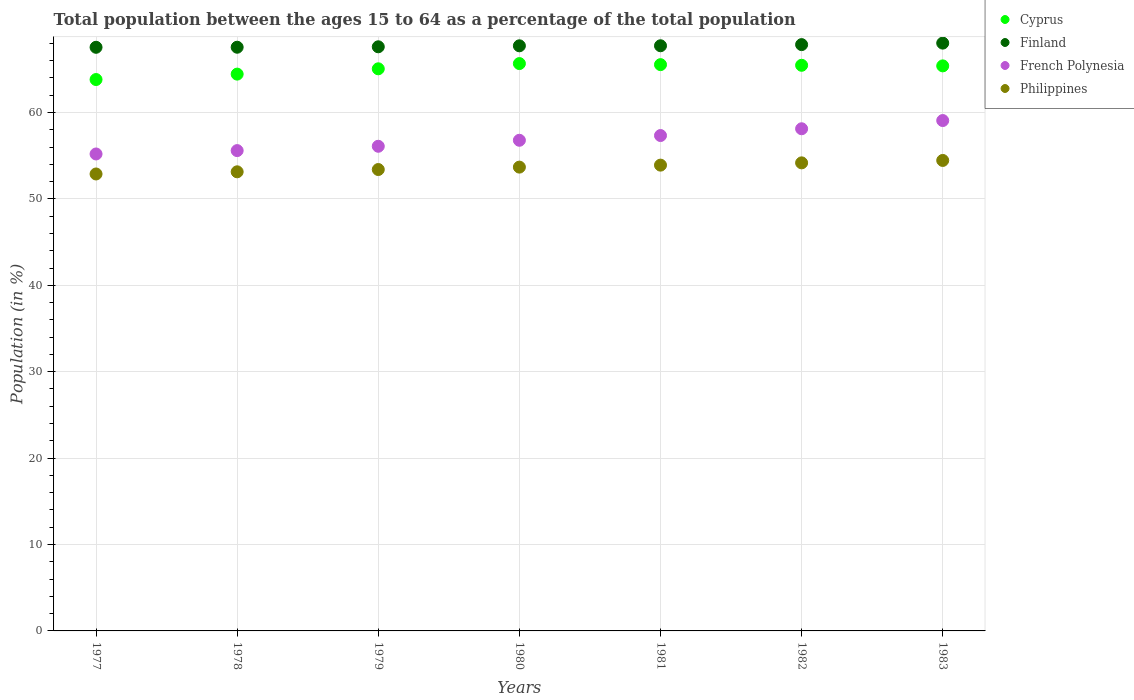How many different coloured dotlines are there?
Keep it short and to the point. 4. What is the percentage of the population ages 15 to 64 in French Polynesia in 1979?
Your answer should be very brief. 56.09. Across all years, what is the maximum percentage of the population ages 15 to 64 in Philippines?
Provide a short and direct response. 54.45. Across all years, what is the minimum percentage of the population ages 15 to 64 in French Polynesia?
Offer a very short reply. 55.2. What is the total percentage of the population ages 15 to 64 in Cyprus in the graph?
Your response must be concise. 455.35. What is the difference between the percentage of the population ages 15 to 64 in Philippines in 1978 and that in 1982?
Give a very brief answer. -1.04. What is the difference between the percentage of the population ages 15 to 64 in French Polynesia in 1980 and the percentage of the population ages 15 to 64 in Finland in 1982?
Your response must be concise. -11.07. What is the average percentage of the population ages 15 to 64 in French Polynesia per year?
Ensure brevity in your answer.  56.88. In the year 1977, what is the difference between the percentage of the population ages 15 to 64 in Finland and percentage of the population ages 15 to 64 in Philippines?
Give a very brief answer. 14.66. In how many years, is the percentage of the population ages 15 to 64 in Finland greater than 18?
Keep it short and to the point. 7. What is the ratio of the percentage of the population ages 15 to 64 in Cyprus in 1980 to that in 1982?
Provide a succinct answer. 1. Is the difference between the percentage of the population ages 15 to 64 in Finland in 1977 and 1982 greater than the difference between the percentage of the population ages 15 to 64 in Philippines in 1977 and 1982?
Your response must be concise. Yes. What is the difference between the highest and the second highest percentage of the population ages 15 to 64 in Cyprus?
Offer a terse response. 0.12. What is the difference between the highest and the lowest percentage of the population ages 15 to 64 in Philippines?
Your answer should be very brief. 1.57. Is the sum of the percentage of the population ages 15 to 64 in Cyprus in 1978 and 1982 greater than the maximum percentage of the population ages 15 to 64 in Philippines across all years?
Keep it short and to the point. Yes. Does the percentage of the population ages 15 to 64 in Cyprus monotonically increase over the years?
Make the answer very short. No. Is the percentage of the population ages 15 to 64 in Cyprus strictly greater than the percentage of the population ages 15 to 64 in Finland over the years?
Provide a short and direct response. No. Is the percentage of the population ages 15 to 64 in Philippines strictly less than the percentage of the population ages 15 to 64 in French Polynesia over the years?
Provide a short and direct response. Yes. How many dotlines are there?
Your answer should be compact. 4. Are the values on the major ticks of Y-axis written in scientific E-notation?
Give a very brief answer. No. Does the graph contain any zero values?
Your answer should be very brief. No. Where does the legend appear in the graph?
Provide a short and direct response. Top right. How are the legend labels stacked?
Your answer should be very brief. Vertical. What is the title of the graph?
Offer a terse response. Total population between the ages 15 to 64 as a percentage of the total population. Does "Egypt, Arab Rep." appear as one of the legend labels in the graph?
Offer a very short reply. No. What is the Population (in %) of Cyprus in 1977?
Your answer should be very brief. 63.81. What is the Population (in %) of Finland in 1977?
Keep it short and to the point. 67.54. What is the Population (in %) of French Polynesia in 1977?
Offer a very short reply. 55.2. What is the Population (in %) in Philippines in 1977?
Offer a terse response. 52.88. What is the Population (in %) of Cyprus in 1978?
Make the answer very short. 64.44. What is the Population (in %) of Finland in 1978?
Keep it short and to the point. 67.55. What is the Population (in %) of French Polynesia in 1978?
Keep it short and to the point. 55.59. What is the Population (in %) of Philippines in 1978?
Offer a terse response. 53.13. What is the Population (in %) of Cyprus in 1979?
Provide a succinct answer. 65.05. What is the Population (in %) of Finland in 1979?
Ensure brevity in your answer.  67.6. What is the Population (in %) in French Polynesia in 1979?
Your answer should be compact. 56.09. What is the Population (in %) of Philippines in 1979?
Offer a very short reply. 53.4. What is the Population (in %) of Cyprus in 1980?
Make the answer very short. 65.66. What is the Population (in %) of Finland in 1980?
Your answer should be compact. 67.72. What is the Population (in %) of French Polynesia in 1980?
Your answer should be compact. 56.78. What is the Population (in %) in Philippines in 1980?
Your answer should be compact. 53.68. What is the Population (in %) in Cyprus in 1981?
Give a very brief answer. 65.54. What is the Population (in %) of Finland in 1981?
Your response must be concise. 67.72. What is the Population (in %) of French Polynesia in 1981?
Provide a short and direct response. 57.33. What is the Population (in %) in Philippines in 1981?
Your response must be concise. 53.91. What is the Population (in %) in Cyprus in 1982?
Give a very brief answer. 65.46. What is the Population (in %) of Finland in 1982?
Keep it short and to the point. 67.85. What is the Population (in %) of French Polynesia in 1982?
Offer a terse response. 58.11. What is the Population (in %) in Philippines in 1982?
Provide a short and direct response. 54.17. What is the Population (in %) of Cyprus in 1983?
Provide a short and direct response. 65.39. What is the Population (in %) in Finland in 1983?
Your response must be concise. 68.03. What is the Population (in %) in French Polynesia in 1983?
Your response must be concise. 59.07. What is the Population (in %) of Philippines in 1983?
Your answer should be very brief. 54.45. Across all years, what is the maximum Population (in %) in Cyprus?
Your answer should be very brief. 65.66. Across all years, what is the maximum Population (in %) of Finland?
Your answer should be compact. 68.03. Across all years, what is the maximum Population (in %) in French Polynesia?
Give a very brief answer. 59.07. Across all years, what is the maximum Population (in %) in Philippines?
Provide a short and direct response. 54.45. Across all years, what is the minimum Population (in %) in Cyprus?
Your answer should be very brief. 63.81. Across all years, what is the minimum Population (in %) of Finland?
Provide a short and direct response. 67.54. Across all years, what is the minimum Population (in %) in French Polynesia?
Provide a short and direct response. 55.2. Across all years, what is the minimum Population (in %) in Philippines?
Keep it short and to the point. 52.88. What is the total Population (in %) in Cyprus in the graph?
Offer a very short reply. 455.35. What is the total Population (in %) of Finland in the graph?
Offer a terse response. 474.01. What is the total Population (in %) of French Polynesia in the graph?
Ensure brevity in your answer.  398.17. What is the total Population (in %) of Philippines in the graph?
Offer a very short reply. 375.61. What is the difference between the Population (in %) of Cyprus in 1977 and that in 1978?
Provide a succinct answer. -0.63. What is the difference between the Population (in %) in Finland in 1977 and that in 1978?
Your answer should be very brief. -0.01. What is the difference between the Population (in %) in French Polynesia in 1977 and that in 1978?
Ensure brevity in your answer.  -0.39. What is the difference between the Population (in %) of Philippines in 1977 and that in 1978?
Your response must be concise. -0.25. What is the difference between the Population (in %) of Cyprus in 1977 and that in 1979?
Ensure brevity in your answer.  -1.24. What is the difference between the Population (in %) in Finland in 1977 and that in 1979?
Provide a short and direct response. -0.06. What is the difference between the Population (in %) in French Polynesia in 1977 and that in 1979?
Give a very brief answer. -0.89. What is the difference between the Population (in %) in Philippines in 1977 and that in 1979?
Your response must be concise. -0.52. What is the difference between the Population (in %) of Cyprus in 1977 and that in 1980?
Give a very brief answer. -1.85. What is the difference between the Population (in %) in Finland in 1977 and that in 1980?
Offer a very short reply. -0.17. What is the difference between the Population (in %) of French Polynesia in 1977 and that in 1980?
Your answer should be compact. -1.58. What is the difference between the Population (in %) in Philippines in 1977 and that in 1980?
Provide a succinct answer. -0.79. What is the difference between the Population (in %) of Cyprus in 1977 and that in 1981?
Ensure brevity in your answer.  -1.72. What is the difference between the Population (in %) of Finland in 1977 and that in 1981?
Provide a succinct answer. -0.18. What is the difference between the Population (in %) in French Polynesia in 1977 and that in 1981?
Offer a very short reply. -2.13. What is the difference between the Population (in %) in Philippines in 1977 and that in 1981?
Your answer should be compact. -1.02. What is the difference between the Population (in %) in Cyprus in 1977 and that in 1982?
Ensure brevity in your answer.  -1.65. What is the difference between the Population (in %) of Finland in 1977 and that in 1982?
Your answer should be compact. -0.31. What is the difference between the Population (in %) of French Polynesia in 1977 and that in 1982?
Give a very brief answer. -2.92. What is the difference between the Population (in %) of Philippines in 1977 and that in 1982?
Offer a very short reply. -1.29. What is the difference between the Population (in %) of Cyprus in 1977 and that in 1983?
Offer a very short reply. -1.58. What is the difference between the Population (in %) in Finland in 1977 and that in 1983?
Give a very brief answer. -0.48. What is the difference between the Population (in %) of French Polynesia in 1977 and that in 1983?
Give a very brief answer. -3.87. What is the difference between the Population (in %) of Philippines in 1977 and that in 1983?
Your answer should be very brief. -1.57. What is the difference between the Population (in %) of Cyprus in 1978 and that in 1979?
Provide a short and direct response. -0.62. What is the difference between the Population (in %) in Finland in 1978 and that in 1979?
Offer a terse response. -0.05. What is the difference between the Population (in %) in French Polynesia in 1978 and that in 1979?
Keep it short and to the point. -0.5. What is the difference between the Population (in %) in Philippines in 1978 and that in 1979?
Your response must be concise. -0.26. What is the difference between the Population (in %) in Cyprus in 1978 and that in 1980?
Your answer should be compact. -1.22. What is the difference between the Population (in %) of Finland in 1978 and that in 1980?
Provide a short and direct response. -0.16. What is the difference between the Population (in %) of French Polynesia in 1978 and that in 1980?
Your answer should be very brief. -1.2. What is the difference between the Population (in %) of Philippines in 1978 and that in 1980?
Provide a succinct answer. -0.54. What is the difference between the Population (in %) in Cyprus in 1978 and that in 1981?
Provide a short and direct response. -1.1. What is the difference between the Population (in %) in Finland in 1978 and that in 1981?
Give a very brief answer. -0.17. What is the difference between the Population (in %) of French Polynesia in 1978 and that in 1981?
Offer a very short reply. -1.74. What is the difference between the Population (in %) of Philippines in 1978 and that in 1981?
Your response must be concise. -0.77. What is the difference between the Population (in %) of Cyprus in 1978 and that in 1982?
Offer a very short reply. -1.02. What is the difference between the Population (in %) of Finland in 1978 and that in 1982?
Your response must be concise. -0.3. What is the difference between the Population (in %) in French Polynesia in 1978 and that in 1982?
Provide a succinct answer. -2.53. What is the difference between the Population (in %) of Philippines in 1978 and that in 1982?
Provide a succinct answer. -1.04. What is the difference between the Population (in %) of Cyprus in 1978 and that in 1983?
Your answer should be compact. -0.95. What is the difference between the Population (in %) of Finland in 1978 and that in 1983?
Your response must be concise. -0.48. What is the difference between the Population (in %) in French Polynesia in 1978 and that in 1983?
Your response must be concise. -3.48. What is the difference between the Population (in %) of Philippines in 1978 and that in 1983?
Ensure brevity in your answer.  -1.32. What is the difference between the Population (in %) in Cyprus in 1979 and that in 1980?
Your response must be concise. -0.6. What is the difference between the Population (in %) in Finland in 1979 and that in 1980?
Provide a succinct answer. -0.11. What is the difference between the Population (in %) in French Polynesia in 1979 and that in 1980?
Offer a terse response. -0.69. What is the difference between the Population (in %) of Philippines in 1979 and that in 1980?
Offer a terse response. -0.28. What is the difference between the Population (in %) of Cyprus in 1979 and that in 1981?
Provide a succinct answer. -0.48. What is the difference between the Population (in %) of Finland in 1979 and that in 1981?
Ensure brevity in your answer.  -0.12. What is the difference between the Population (in %) in French Polynesia in 1979 and that in 1981?
Ensure brevity in your answer.  -1.24. What is the difference between the Population (in %) in Philippines in 1979 and that in 1981?
Your response must be concise. -0.51. What is the difference between the Population (in %) in Cyprus in 1979 and that in 1982?
Your answer should be compact. -0.41. What is the difference between the Population (in %) in Finland in 1979 and that in 1982?
Give a very brief answer. -0.25. What is the difference between the Population (in %) of French Polynesia in 1979 and that in 1982?
Offer a terse response. -2.03. What is the difference between the Population (in %) of Philippines in 1979 and that in 1982?
Your answer should be compact. -0.77. What is the difference between the Population (in %) in Cyprus in 1979 and that in 1983?
Keep it short and to the point. -0.34. What is the difference between the Population (in %) in Finland in 1979 and that in 1983?
Provide a succinct answer. -0.43. What is the difference between the Population (in %) of French Polynesia in 1979 and that in 1983?
Your answer should be very brief. -2.98. What is the difference between the Population (in %) in Philippines in 1979 and that in 1983?
Your response must be concise. -1.05. What is the difference between the Population (in %) of Cyprus in 1980 and that in 1981?
Offer a terse response. 0.12. What is the difference between the Population (in %) in Finland in 1980 and that in 1981?
Offer a terse response. -0. What is the difference between the Population (in %) of French Polynesia in 1980 and that in 1981?
Offer a terse response. -0.55. What is the difference between the Population (in %) in Philippines in 1980 and that in 1981?
Offer a very short reply. -0.23. What is the difference between the Population (in %) of Cyprus in 1980 and that in 1982?
Your answer should be very brief. 0.2. What is the difference between the Population (in %) in Finland in 1980 and that in 1982?
Offer a terse response. -0.14. What is the difference between the Population (in %) of French Polynesia in 1980 and that in 1982?
Give a very brief answer. -1.33. What is the difference between the Population (in %) of Philippines in 1980 and that in 1982?
Make the answer very short. -0.49. What is the difference between the Population (in %) of Cyprus in 1980 and that in 1983?
Your response must be concise. 0.27. What is the difference between the Population (in %) of Finland in 1980 and that in 1983?
Provide a short and direct response. -0.31. What is the difference between the Population (in %) of French Polynesia in 1980 and that in 1983?
Ensure brevity in your answer.  -2.28. What is the difference between the Population (in %) in Philippines in 1980 and that in 1983?
Provide a short and direct response. -0.77. What is the difference between the Population (in %) in Cyprus in 1981 and that in 1982?
Offer a terse response. 0.07. What is the difference between the Population (in %) in Finland in 1981 and that in 1982?
Offer a terse response. -0.13. What is the difference between the Population (in %) of French Polynesia in 1981 and that in 1982?
Provide a succinct answer. -0.78. What is the difference between the Population (in %) in Philippines in 1981 and that in 1982?
Keep it short and to the point. -0.26. What is the difference between the Population (in %) in Cyprus in 1981 and that in 1983?
Your response must be concise. 0.14. What is the difference between the Population (in %) in Finland in 1981 and that in 1983?
Make the answer very short. -0.31. What is the difference between the Population (in %) of French Polynesia in 1981 and that in 1983?
Ensure brevity in your answer.  -1.74. What is the difference between the Population (in %) of Philippines in 1981 and that in 1983?
Your answer should be very brief. -0.54. What is the difference between the Population (in %) in Cyprus in 1982 and that in 1983?
Your answer should be very brief. 0.07. What is the difference between the Population (in %) in Finland in 1982 and that in 1983?
Your answer should be very brief. -0.17. What is the difference between the Population (in %) of French Polynesia in 1982 and that in 1983?
Keep it short and to the point. -0.95. What is the difference between the Population (in %) of Philippines in 1982 and that in 1983?
Your response must be concise. -0.28. What is the difference between the Population (in %) of Cyprus in 1977 and the Population (in %) of Finland in 1978?
Make the answer very short. -3.74. What is the difference between the Population (in %) in Cyprus in 1977 and the Population (in %) in French Polynesia in 1978?
Offer a terse response. 8.22. What is the difference between the Population (in %) of Cyprus in 1977 and the Population (in %) of Philippines in 1978?
Your answer should be compact. 10.68. What is the difference between the Population (in %) of Finland in 1977 and the Population (in %) of French Polynesia in 1978?
Keep it short and to the point. 11.96. What is the difference between the Population (in %) in Finland in 1977 and the Population (in %) in Philippines in 1978?
Offer a very short reply. 14.41. What is the difference between the Population (in %) in French Polynesia in 1977 and the Population (in %) in Philippines in 1978?
Provide a short and direct response. 2.06. What is the difference between the Population (in %) of Cyprus in 1977 and the Population (in %) of Finland in 1979?
Keep it short and to the point. -3.79. What is the difference between the Population (in %) of Cyprus in 1977 and the Population (in %) of French Polynesia in 1979?
Keep it short and to the point. 7.72. What is the difference between the Population (in %) in Cyprus in 1977 and the Population (in %) in Philippines in 1979?
Your answer should be very brief. 10.41. What is the difference between the Population (in %) in Finland in 1977 and the Population (in %) in French Polynesia in 1979?
Offer a terse response. 11.45. What is the difference between the Population (in %) of Finland in 1977 and the Population (in %) of Philippines in 1979?
Give a very brief answer. 14.15. What is the difference between the Population (in %) of French Polynesia in 1977 and the Population (in %) of Philippines in 1979?
Your answer should be very brief. 1.8. What is the difference between the Population (in %) in Cyprus in 1977 and the Population (in %) in Finland in 1980?
Provide a succinct answer. -3.9. What is the difference between the Population (in %) of Cyprus in 1977 and the Population (in %) of French Polynesia in 1980?
Give a very brief answer. 7.03. What is the difference between the Population (in %) in Cyprus in 1977 and the Population (in %) in Philippines in 1980?
Make the answer very short. 10.14. What is the difference between the Population (in %) in Finland in 1977 and the Population (in %) in French Polynesia in 1980?
Provide a succinct answer. 10.76. What is the difference between the Population (in %) of Finland in 1977 and the Population (in %) of Philippines in 1980?
Your answer should be very brief. 13.87. What is the difference between the Population (in %) in French Polynesia in 1977 and the Population (in %) in Philippines in 1980?
Offer a terse response. 1.52. What is the difference between the Population (in %) in Cyprus in 1977 and the Population (in %) in Finland in 1981?
Offer a terse response. -3.91. What is the difference between the Population (in %) in Cyprus in 1977 and the Population (in %) in French Polynesia in 1981?
Give a very brief answer. 6.48. What is the difference between the Population (in %) in Cyprus in 1977 and the Population (in %) in Philippines in 1981?
Give a very brief answer. 9.91. What is the difference between the Population (in %) in Finland in 1977 and the Population (in %) in French Polynesia in 1981?
Offer a very short reply. 10.21. What is the difference between the Population (in %) of Finland in 1977 and the Population (in %) of Philippines in 1981?
Provide a short and direct response. 13.64. What is the difference between the Population (in %) in French Polynesia in 1977 and the Population (in %) in Philippines in 1981?
Ensure brevity in your answer.  1.29. What is the difference between the Population (in %) in Cyprus in 1977 and the Population (in %) in Finland in 1982?
Make the answer very short. -4.04. What is the difference between the Population (in %) of Cyprus in 1977 and the Population (in %) of French Polynesia in 1982?
Your response must be concise. 5.7. What is the difference between the Population (in %) of Cyprus in 1977 and the Population (in %) of Philippines in 1982?
Offer a very short reply. 9.64. What is the difference between the Population (in %) of Finland in 1977 and the Population (in %) of French Polynesia in 1982?
Your response must be concise. 9.43. What is the difference between the Population (in %) in Finland in 1977 and the Population (in %) in Philippines in 1982?
Offer a terse response. 13.37. What is the difference between the Population (in %) in French Polynesia in 1977 and the Population (in %) in Philippines in 1982?
Offer a very short reply. 1.03. What is the difference between the Population (in %) in Cyprus in 1977 and the Population (in %) in Finland in 1983?
Your answer should be very brief. -4.21. What is the difference between the Population (in %) of Cyprus in 1977 and the Population (in %) of French Polynesia in 1983?
Ensure brevity in your answer.  4.75. What is the difference between the Population (in %) in Cyprus in 1977 and the Population (in %) in Philippines in 1983?
Give a very brief answer. 9.36. What is the difference between the Population (in %) of Finland in 1977 and the Population (in %) of French Polynesia in 1983?
Your answer should be compact. 8.48. What is the difference between the Population (in %) in Finland in 1977 and the Population (in %) in Philippines in 1983?
Provide a short and direct response. 13.09. What is the difference between the Population (in %) of French Polynesia in 1977 and the Population (in %) of Philippines in 1983?
Keep it short and to the point. 0.75. What is the difference between the Population (in %) of Cyprus in 1978 and the Population (in %) of Finland in 1979?
Your answer should be compact. -3.16. What is the difference between the Population (in %) in Cyprus in 1978 and the Population (in %) in French Polynesia in 1979?
Your response must be concise. 8.35. What is the difference between the Population (in %) in Cyprus in 1978 and the Population (in %) in Philippines in 1979?
Ensure brevity in your answer.  11.04. What is the difference between the Population (in %) in Finland in 1978 and the Population (in %) in French Polynesia in 1979?
Your answer should be compact. 11.46. What is the difference between the Population (in %) in Finland in 1978 and the Population (in %) in Philippines in 1979?
Offer a very short reply. 14.15. What is the difference between the Population (in %) of French Polynesia in 1978 and the Population (in %) of Philippines in 1979?
Your answer should be compact. 2.19. What is the difference between the Population (in %) of Cyprus in 1978 and the Population (in %) of Finland in 1980?
Your answer should be very brief. -3.28. What is the difference between the Population (in %) of Cyprus in 1978 and the Population (in %) of French Polynesia in 1980?
Offer a very short reply. 7.66. What is the difference between the Population (in %) in Cyprus in 1978 and the Population (in %) in Philippines in 1980?
Ensure brevity in your answer.  10.76. What is the difference between the Population (in %) in Finland in 1978 and the Population (in %) in French Polynesia in 1980?
Your response must be concise. 10.77. What is the difference between the Population (in %) in Finland in 1978 and the Population (in %) in Philippines in 1980?
Keep it short and to the point. 13.88. What is the difference between the Population (in %) in French Polynesia in 1978 and the Population (in %) in Philippines in 1980?
Make the answer very short. 1.91. What is the difference between the Population (in %) in Cyprus in 1978 and the Population (in %) in Finland in 1981?
Give a very brief answer. -3.28. What is the difference between the Population (in %) in Cyprus in 1978 and the Population (in %) in French Polynesia in 1981?
Your answer should be compact. 7.11. What is the difference between the Population (in %) in Cyprus in 1978 and the Population (in %) in Philippines in 1981?
Provide a short and direct response. 10.53. What is the difference between the Population (in %) in Finland in 1978 and the Population (in %) in French Polynesia in 1981?
Provide a short and direct response. 10.22. What is the difference between the Population (in %) of Finland in 1978 and the Population (in %) of Philippines in 1981?
Provide a succinct answer. 13.65. What is the difference between the Population (in %) in French Polynesia in 1978 and the Population (in %) in Philippines in 1981?
Provide a short and direct response. 1.68. What is the difference between the Population (in %) of Cyprus in 1978 and the Population (in %) of Finland in 1982?
Offer a terse response. -3.41. What is the difference between the Population (in %) in Cyprus in 1978 and the Population (in %) in French Polynesia in 1982?
Offer a terse response. 6.32. What is the difference between the Population (in %) of Cyprus in 1978 and the Population (in %) of Philippines in 1982?
Offer a terse response. 10.27. What is the difference between the Population (in %) in Finland in 1978 and the Population (in %) in French Polynesia in 1982?
Give a very brief answer. 9.44. What is the difference between the Population (in %) in Finland in 1978 and the Population (in %) in Philippines in 1982?
Offer a very short reply. 13.38. What is the difference between the Population (in %) in French Polynesia in 1978 and the Population (in %) in Philippines in 1982?
Make the answer very short. 1.42. What is the difference between the Population (in %) of Cyprus in 1978 and the Population (in %) of Finland in 1983?
Your answer should be compact. -3.59. What is the difference between the Population (in %) in Cyprus in 1978 and the Population (in %) in French Polynesia in 1983?
Your answer should be compact. 5.37. What is the difference between the Population (in %) of Cyprus in 1978 and the Population (in %) of Philippines in 1983?
Your response must be concise. 9.99. What is the difference between the Population (in %) of Finland in 1978 and the Population (in %) of French Polynesia in 1983?
Offer a very short reply. 8.49. What is the difference between the Population (in %) of Finland in 1978 and the Population (in %) of Philippines in 1983?
Keep it short and to the point. 13.1. What is the difference between the Population (in %) in French Polynesia in 1978 and the Population (in %) in Philippines in 1983?
Offer a terse response. 1.14. What is the difference between the Population (in %) in Cyprus in 1979 and the Population (in %) in Finland in 1980?
Offer a very short reply. -2.66. What is the difference between the Population (in %) of Cyprus in 1979 and the Population (in %) of French Polynesia in 1980?
Your answer should be compact. 8.27. What is the difference between the Population (in %) of Cyprus in 1979 and the Population (in %) of Philippines in 1980?
Ensure brevity in your answer.  11.38. What is the difference between the Population (in %) of Finland in 1979 and the Population (in %) of French Polynesia in 1980?
Keep it short and to the point. 10.82. What is the difference between the Population (in %) of Finland in 1979 and the Population (in %) of Philippines in 1980?
Offer a terse response. 13.92. What is the difference between the Population (in %) of French Polynesia in 1979 and the Population (in %) of Philippines in 1980?
Your response must be concise. 2.41. What is the difference between the Population (in %) of Cyprus in 1979 and the Population (in %) of Finland in 1981?
Give a very brief answer. -2.67. What is the difference between the Population (in %) in Cyprus in 1979 and the Population (in %) in French Polynesia in 1981?
Ensure brevity in your answer.  7.72. What is the difference between the Population (in %) of Cyprus in 1979 and the Population (in %) of Philippines in 1981?
Provide a succinct answer. 11.15. What is the difference between the Population (in %) of Finland in 1979 and the Population (in %) of French Polynesia in 1981?
Offer a very short reply. 10.27. What is the difference between the Population (in %) in Finland in 1979 and the Population (in %) in Philippines in 1981?
Keep it short and to the point. 13.7. What is the difference between the Population (in %) in French Polynesia in 1979 and the Population (in %) in Philippines in 1981?
Your response must be concise. 2.18. What is the difference between the Population (in %) of Cyprus in 1979 and the Population (in %) of Finland in 1982?
Give a very brief answer. -2.8. What is the difference between the Population (in %) in Cyprus in 1979 and the Population (in %) in French Polynesia in 1982?
Offer a terse response. 6.94. What is the difference between the Population (in %) in Cyprus in 1979 and the Population (in %) in Philippines in 1982?
Offer a terse response. 10.89. What is the difference between the Population (in %) in Finland in 1979 and the Population (in %) in French Polynesia in 1982?
Your answer should be compact. 9.49. What is the difference between the Population (in %) of Finland in 1979 and the Population (in %) of Philippines in 1982?
Your answer should be very brief. 13.43. What is the difference between the Population (in %) in French Polynesia in 1979 and the Population (in %) in Philippines in 1982?
Your response must be concise. 1.92. What is the difference between the Population (in %) of Cyprus in 1979 and the Population (in %) of Finland in 1983?
Your response must be concise. -2.97. What is the difference between the Population (in %) in Cyprus in 1979 and the Population (in %) in French Polynesia in 1983?
Provide a succinct answer. 5.99. What is the difference between the Population (in %) of Cyprus in 1979 and the Population (in %) of Philippines in 1983?
Offer a terse response. 10.61. What is the difference between the Population (in %) in Finland in 1979 and the Population (in %) in French Polynesia in 1983?
Your answer should be compact. 8.54. What is the difference between the Population (in %) of Finland in 1979 and the Population (in %) of Philippines in 1983?
Your answer should be compact. 13.15. What is the difference between the Population (in %) of French Polynesia in 1979 and the Population (in %) of Philippines in 1983?
Your answer should be very brief. 1.64. What is the difference between the Population (in %) of Cyprus in 1980 and the Population (in %) of Finland in 1981?
Offer a very short reply. -2.06. What is the difference between the Population (in %) of Cyprus in 1980 and the Population (in %) of French Polynesia in 1981?
Make the answer very short. 8.33. What is the difference between the Population (in %) of Cyprus in 1980 and the Population (in %) of Philippines in 1981?
Give a very brief answer. 11.75. What is the difference between the Population (in %) in Finland in 1980 and the Population (in %) in French Polynesia in 1981?
Provide a succinct answer. 10.38. What is the difference between the Population (in %) in Finland in 1980 and the Population (in %) in Philippines in 1981?
Give a very brief answer. 13.81. What is the difference between the Population (in %) in French Polynesia in 1980 and the Population (in %) in Philippines in 1981?
Ensure brevity in your answer.  2.88. What is the difference between the Population (in %) in Cyprus in 1980 and the Population (in %) in Finland in 1982?
Ensure brevity in your answer.  -2.19. What is the difference between the Population (in %) of Cyprus in 1980 and the Population (in %) of French Polynesia in 1982?
Your answer should be compact. 7.54. What is the difference between the Population (in %) of Cyprus in 1980 and the Population (in %) of Philippines in 1982?
Offer a very short reply. 11.49. What is the difference between the Population (in %) of Finland in 1980 and the Population (in %) of French Polynesia in 1982?
Offer a very short reply. 9.6. What is the difference between the Population (in %) of Finland in 1980 and the Population (in %) of Philippines in 1982?
Your response must be concise. 13.55. What is the difference between the Population (in %) in French Polynesia in 1980 and the Population (in %) in Philippines in 1982?
Offer a terse response. 2.61. What is the difference between the Population (in %) in Cyprus in 1980 and the Population (in %) in Finland in 1983?
Your response must be concise. -2.37. What is the difference between the Population (in %) of Cyprus in 1980 and the Population (in %) of French Polynesia in 1983?
Offer a very short reply. 6.59. What is the difference between the Population (in %) of Cyprus in 1980 and the Population (in %) of Philippines in 1983?
Make the answer very short. 11.21. What is the difference between the Population (in %) in Finland in 1980 and the Population (in %) in French Polynesia in 1983?
Make the answer very short. 8.65. What is the difference between the Population (in %) of Finland in 1980 and the Population (in %) of Philippines in 1983?
Offer a terse response. 13.27. What is the difference between the Population (in %) of French Polynesia in 1980 and the Population (in %) of Philippines in 1983?
Offer a very short reply. 2.33. What is the difference between the Population (in %) of Cyprus in 1981 and the Population (in %) of Finland in 1982?
Your answer should be compact. -2.32. What is the difference between the Population (in %) in Cyprus in 1981 and the Population (in %) in French Polynesia in 1982?
Give a very brief answer. 7.42. What is the difference between the Population (in %) in Cyprus in 1981 and the Population (in %) in Philippines in 1982?
Give a very brief answer. 11.37. What is the difference between the Population (in %) in Finland in 1981 and the Population (in %) in French Polynesia in 1982?
Offer a terse response. 9.61. What is the difference between the Population (in %) in Finland in 1981 and the Population (in %) in Philippines in 1982?
Your answer should be compact. 13.55. What is the difference between the Population (in %) of French Polynesia in 1981 and the Population (in %) of Philippines in 1982?
Your answer should be compact. 3.16. What is the difference between the Population (in %) of Cyprus in 1981 and the Population (in %) of Finland in 1983?
Ensure brevity in your answer.  -2.49. What is the difference between the Population (in %) of Cyprus in 1981 and the Population (in %) of French Polynesia in 1983?
Offer a very short reply. 6.47. What is the difference between the Population (in %) in Cyprus in 1981 and the Population (in %) in Philippines in 1983?
Your answer should be very brief. 11.09. What is the difference between the Population (in %) in Finland in 1981 and the Population (in %) in French Polynesia in 1983?
Make the answer very short. 8.65. What is the difference between the Population (in %) in Finland in 1981 and the Population (in %) in Philippines in 1983?
Provide a short and direct response. 13.27. What is the difference between the Population (in %) in French Polynesia in 1981 and the Population (in %) in Philippines in 1983?
Your answer should be compact. 2.88. What is the difference between the Population (in %) in Cyprus in 1982 and the Population (in %) in Finland in 1983?
Offer a terse response. -2.57. What is the difference between the Population (in %) in Cyprus in 1982 and the Population (in %) in French Polynesia in 1983?
Your answer should be very brief. 6.4. What is the difference between the Population (in %) of Cyprus in 1982 and the Population (in %) of Philippines in 1983?
Give a very brief answer. 11.01. What is the difference between the Population (in %) in Finland in 1982 and the Population (in %) in French Polynesia in 1983?
Keep it short and to the point. 8.79. What is the difference between the Population (in %) of Finland in 1982 and the Population (in %) of Philippines in 1983?
Your answer should be compact. 13.4. What is the difference between the Population (in %) in French Polynesia in 1982 and the Population (in %) in Philippines in 1983?
Your answer should be compact. 3.67. What is the average Population (in %) in Cyprus per year?
Your answer should be compact. 65.05. What is the average Population (in %) in Finland per year?
Your response must be concise. 67.72. What is the average Population (in %) in French Polynesia per year?
Offer a terse response. 56.88. What is the average Population (in %) of Philippines per year?
Your answer should be compact. 53.66. In the year 1977, what is the difference between the Population (in %) in Cyprus and Population (in %) in Finland?
Your response must be concise. -3.73. In the year 1977, what is the difference between the Population (in %) in Cyprus and Population (in %) in French Polynesia?
Your response must be concise. 8.61. In the year 1977, what is the difference between the Population (in %) of Cyprus and Population (in %) of Philippines?
Provide a short and direct response. 10.93. In the year 1977, what is the difference between the Population (in %) in Finland and Population (in %) in French Polynesia?
Keep it short and to the point. 12.35. In the year 1977, what is the difference between the Population (in %) of Finland and Population (in %) of Philippines?
Offer a terse response. 14.66. In the year 1977, what is the difference between the Population (in %) of French Polynesia and Population (in %) of Philippines?
Your answer should be very brief. 2.32. In the year 1978, what is the difference between the Population (in %) in Cyprus and Population (in %) in Finland?
Your answer should be compact. -3.11. In the year 1978, what is the difference between the Population (in %) of Cyprus and Population (in %) of French Polynesia?
Your answer should be compact. 8.85. In the year 1978, what is the difference between the Population (in %) in Cyprus and Population (in %) in Philippines?
Your answer should be very brief. 11.31. In the year 1978, what is the difference between the Population (in %) of Finland and Population (in %) of French Polynesia?
Your answer should be compact. 11.96. In the year 1978, what is the difference between the Population (in %) of Finland and Population (in %) of Philippines?
Your answer should be compact. 14.42. In the year 1978, what is the difference between the Population (in %) in French Polynesia and Population (in %) in Philippines?
Your answer should be very brief. 2.45. In the year 1979, what is the difference between the Population (in %) in Cyprus and Population (in %) in Finland?
Keep it short and to the point. -2.55. In the year 1979, what is the difference between the Population (in %) of Cyprus and Population (in %) of French Polynesia?
Keep it short and to the point. 8.97. In the year 1979, what is the difference between the Population (in %) of Cyprus and Population (in %) of Philippines?
Your response must be concise. 11.66. In the year 1979, what is the difference between the Population (in %) in Finland and Population (in %) in French Polynesia?
Make the answer very short. 11.51. In the year 1979, what is the difference between the Population (in %) in Finland and Population (in %) in Philippines?
Provide a succinct answer. 14.2. In the year 1979, what is the difference between the Population (in %) in French Polynesia and Population (in %) in Philippines?
Make the answer very short. 2.69. In the year 1980, what is the difference between the Population (in %) in Cyprus and Population (in %) in Finland?
Your response must be concise. -2.06. In the year 1980, what is the difference between the Population (in %) in Cyprus and Population (in %) in French Polynesia?
Provide a short and direct response. 8.88. In the year 1980, what is the difference between the Population (in %) of Cyprus and Population (in %) of Philippines?
Provide a short and direct response. 11.98. In the year 1980, what is the difference between the Population (in %) in Finland and Population (in %) in French Polynesia?
Provide a short and direct response. 10.93. In the year 1980, what is the difference between the Population (in %) of Finland and Population (in %) of Philippines?
Provide a succinct answer. 14.04. In the year 1980, what is the difference between the Population (in %) of French Polynesia and Population (in %) of Philippines?
Provide a short and direct response. 3.11. In the year 1981, what is the difference between the Population (in %) in Cyprus and Population (in %) in Finland?
Provide a short and direct response. -2.18. In the year 1981, what is the difference between the Population (in %) of Cyprus and Population (in %) of French Polynesia?
Give a very brief answer. 8.21. In the year 1981, what is the difference between the Population (in %) of Cyprus and Population (in %) of Philippines?
Your answer should be compact. 11.63. In the year 1981, what is the difference between the Population (in %) in Finland and Population (in %) in French Polynesia?
Your answer should be very brief. 10.39. In the year 1981, what is the difference between the Population (in %) in Finland and Population (in %) in Philippines?
Offer a terse response. 13.81. In the year 1981, what is the difference between the Population (in %) in French Polynesia and Population (in %) in Philippines?
Your answer should be compact. 3.43. In the year 1982, what is the difference between the Population (in %) of Cyprus and Population (in %) of Finland?
Provide a succinct answer. -2.39. In the year 1982, what is the difference between the Population (in %) in Cyprus and Population (in %) in French Polynesia?
Offer a very short reply. 7.35. In the year 1982, what is the difference between the Population (in %) of Cyprus and Population (in %) of Philippines?
Provide a short and direct response. 11.29. In the year 1982, what is the difference between the Population (in %) of Finland and Population (in %) of French Polynesia?
Your response must be concise. 9.74. In the year 1982, what is the difference between the Population (in %) of Finland and Population (in %) of Philippines?
Provide a succinct answer. 13.68. In the year 1982, what is the difference between the Population (in %) in French Polynesia and Population (in %) in Philippines?
Make the answer very short. 3.95. In the year 1983, what is the difference between the Population (in %) of Cyprus and Population (in %) of Finland?
Keep it short and to the point. -2.63. In the year 1983, what is the difference between the Population (in %) in Cyprus and Population (in %) in French Polynesia?
Offer a very short reply. 6.33. In the year 1983, what is the difference between the Population (in %) in Cyprus and Population (in %) in Philippines?
Make the answer very short. 10.94. In the year 1983, what is the difference between the Population (in %) in Finland and Population (in %) in French Polynesia?
Offer a very short reply. 8.96. In the year 1983, what is the difference between the Population (in %) in Finland and Population (in %) in Philippines?
Keep it short and to the point. 13.58. In the year 1983, what is the difference between the Population (in %) of French Polynesia and Population (in %) of Philippines?
Your response must be concise. 4.62. What is the ratio of the Population (in %) of Cyprus in 1977 to that in 1978?
Offer a terse response. 0.99. What is the ratio of the Population (in %) of Finland in 1977 to that in 1978?
Ensure brevity in your answer.  1. What is the ratio of the Population (in %) of French Polynesia in 1977 to that in 1978?
Make the answer very short. 0.99. What is the ratio of the Population (in %) in Cyprus in 1977 to that in 1979?
Offer a terse response. 0.98. What is the ratio of the Population (in %) in Finland in 1977 to that in 1979?
Give a very brief answer. 1. What is the ratio of the Population (in %) of French Polynesia in 1977 to that in 1979?
Provide a short and direct response. 0.98. What is the ratio of the Population (in %) of Philippines in 1977 to that in 1979?
Provide a succinct answer. 0.99. What is the ratio of the Population (in %) in Cyprus in 1977 to that in 1980?
Offer a very short reply. 0.97. What is the ratio of the Population (in %) of French Polynesia in 1977 to that in 1980?
Your answer should be very brief. 0.97. What is the ratio of the Population (in %) of Philippines in 1977 to that in 1980?
Your response must be concise. 0.99. What is the ratio of the Population (in %) in Cyprus in 1977 to that in 1981?
Your response must be concise. 0.97. What is the ratio of the Population (in %) of French Polynesia in 1977 to that in 1981?
Ensure brevity in your answer.  0.96. What is the ratio of the Population (in %) in Philippines in 1977 to that in 1981?
Offer a very short reply. 0.98. What is the ratio of the Population (in %) in Cyprus in 1977 to that in 1982?
Provide a short and direct response. 0.97. What is the ratio of the Population (in %) of French Polynesia in 1977 to that in 1982?
Your answer should be compact. 0.95. What is the ratio of the Population (in %) in Philippines in 1977 to that in 1982?
Your response must be concise. 0.98. What is the ratio of the Population (in %) in Cyprus in 1977 to that in 1983?
Your response must be concise. 0.98. What is the ratio of the Population (in %) of French Polynesia in 1977 to that in 1983?
Keep it short and to the point. 0.93. What is the ratio of the Population (in %) in Philippines in 1977 to that in 1983?
Your response must be concise. 0.97. What is the ratio of the Population (in %) of Philippines in 1978 to that in 1979?
Your response must be concise. 0.99. What is the ratio of the Population (in %) of Cyprus in 1978 to that in 1980?
Your answer should be compact. 0.98. What is the ratio of the Population (in %) in Cyprus in 1978 to that in 1981?
Your answer should be compact. 0.98. What is the ratio of the Population (in %) of French Polynesia in 1978 to that in 1981?
Your answer should be very brief. 0.97. What is the ratio of the Population (in %) of Philippines in 1978 to that in 1981?
Offer a terse response. 0.99. What is the ratio of the Population (in %) of Cyprus in 1978 to that in 1982?
Your answer should be compact. 0.98. What is the ratio of the Population (in %) in Finland in 1978 to that in 1982?
Ensure brevity in your answer.  1. What is the ratio of the Population (in %) in French Polynesia in 1978 to that in 1982?
Your answer should be compact. 0.96. What is the ratio of the Population (in %) in Philippines in 1978 to that in 1982?
Offer a terse response. 0.98. What is the ratio of the Population (in %) in Cyprus in 1978 to that in 1983?
Offer a terse response. 0.99. What is the ratio of the Population (in %) of Finland in 1978 to that in 1983?
Provide a short and direct response. 0.99. What is the ratio of the Population (in %) of French Polynesia in 1978 to that in 1983?
Provide a short and direct response. 0.94. What is the ratio of the Population (in %) in Philippines in 1978 to that in 1983?
Provide a succinct answer. 0.98. What is the ratio of the Population (in %) in Cyprus in 1979 to that in 1980?
Keep it short and to the point. 0.99. What is the ratio of the Population (in %) in Finland in 1979 to that in 1981?
Keep it short and to the point. 1. What is the ratio of the Population (in %) of French Polynesia in 1979 to that in 1981?
Your answer should be compact. 0.98. What is the ratio of the Population (in %) of Philippines in 1979 to that in 1981?
Your answer should be very brief. 0.99. What is the ratio of the Population (in %) in Finland in 1979 to that in 1982?
Give a very brief answer. 1. What is the ratio of the Population (in %) of French Polynesia in 1979 to that in 1982?
Offer a very short reply. 0.97. What is the ratio of the Population (in %) of Philippines in 1979 to that in 1982?
Your response must be concise. 0.99. What is the ratio of the Population (in %) of Finland in 1979 to that in 1983?
Keep it short and to the point. 0.99. What is the ratio of the Population (in %) in French Polynesia in 1979 to that in 1983?
Your answer should be very brief. 0.95. What is the ratio of the Population (in %) of Philippines in 1979 to that in 1983?
Keep it short and to the point. 0.98. What is the ratio of the Population (in %) in French Polynesia in 1980 to that in 1981?
Provide a short and direct response. 0.99. What is the ratio of the Population (in %) of Philippines in 1980 to that in 1981?
Your response must be concise. 1. What is the ratio of the Population (in %) in Cyprus in 1980 to that in 1982?
Your response must be concise. 1. What is the ratio of the Population (in %) in French Polynesia in 1980 to that in 1982?
Keep it short and to the point. 0.98. What is the ratio of the Population (in %) in Philippines in 1980 to that in 1982?
Offer a very short reply. 0.99. What is the ratio of the Population (in %) in French Polynesia in 1980 to that in 1983?
Keep it short and to the point. 0.96. What is the ratio of the Population (in %) of Philippines in 1980 to that in 1983?
Your answer should be compact. 0.99. What is the ratio of the Population (in %) of Finland in 1981 to that in 1982?
Make the answer very short. 1. What is the ratio of the Population (in %) of French Polynesia in 1981 to that in 1982?
Your answer should be compact. 0.99. What is the ratio of the Population (in %) in Finland in 1981 to that in 1983?
Offer a terse response. 1. What is the ratio of the Population (in %) of French Polynesia in 1981 to that in 1983?
Your response must be concise. 0.97. What is the ratio of the Population (in %) of Philippines in 1981 to that in 1983?
Ensure brevity in your answer.  0.99. What is the ratio of the Population (in %) in Finland in 1982 to that in 1983?
Offer a terse response. 1. What is the ratio of the Population (in %) in French Polynesia in 1982 to that in 1983?
Offer a very short reply. 0.98. What is the ratio of the Population (in %) in Philippines in 1982 to that in 1983?
Provide a short and direct response. 0.99. What is the difference between the highest and the second highest Population (in %) of Cyprus?
Your answer should be compact. 0.12. What is the difference between the highest and the second highest Population (in %) in Finland?
Give a very brief answer. 0.17. What is the difference between the highest and the second highest Population (in %) of French Polynesia?
Offer a terse response. 0.95. What is the difference between the highest and the second highest Population (in %) in Philippines?
Provide a short and direct response. 0.28. What is the difference between the highest and the lowest Population (in %) of Cyprus?
Provide a short and direct response. 1.85. What is the difference between the highest and the lowest Population (in %) of Finland?
Offer a very short reply. 0.48. What is the difference between the highest and the lowest Population (in %) in French Polynesia?
Ensure brevity in your answer.  3.87. What is the difference between the highest and the lowest Population (in %) in Philippines?
Keep it short and to the point. 1.57. 